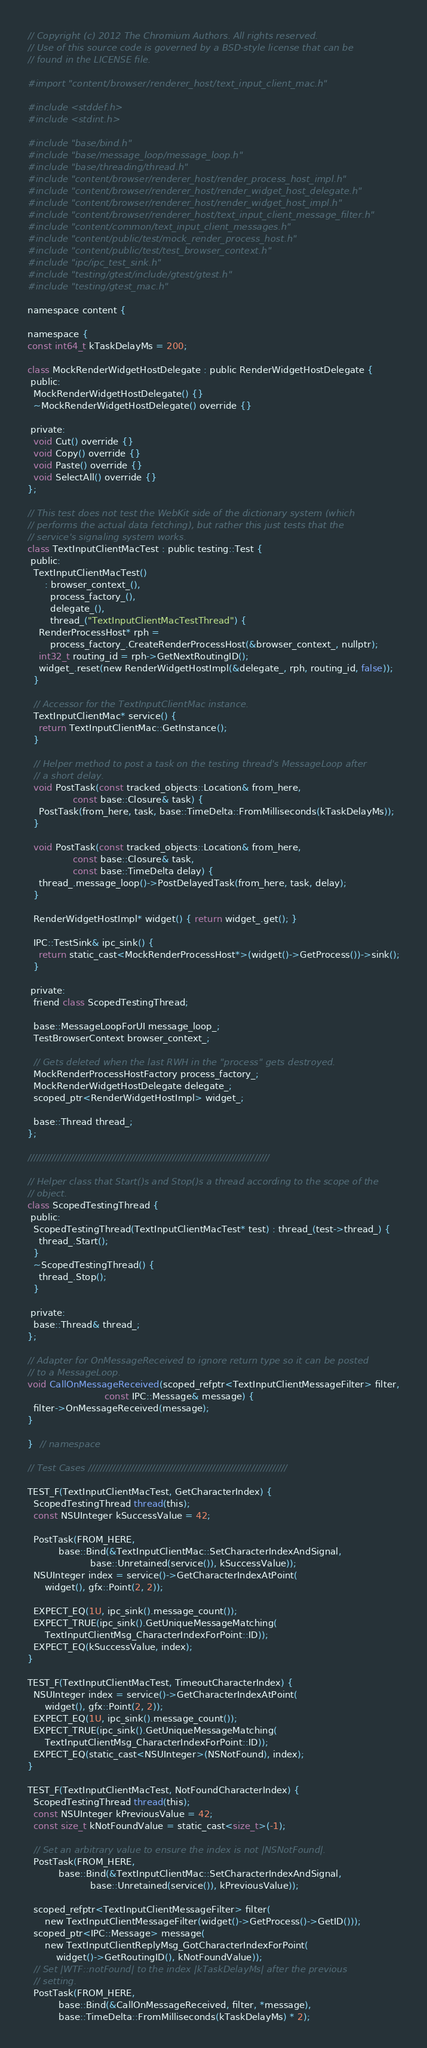<code> <loc_0><loc_0><loc_500><loc_500><_ObjectiveC_>// Copyright (c) 2012 The Chromium Authors. All rights reserved.
// Use of this source code is governed by a BSD-style license that can be
// found in the LICENSE file.

#import "content/browser/renderer_host/text_input_client_mac.h"

#include <stddef.h>
#include <stdint.h>

#include "base/bind.h"
#include "base/message_loop/message_loop.h"
#include "base/threading/thread.h"
#include "content/browser/renderer_host/render_process_host_impl.h"
#include "content/browser/renderer_host/render_widget_host_delegate.h"
#include "content/browser/renderer_host/render_widget_host_impl.h"
#include "content/browser/renderer_host/text_input_client_message_filter.h"
#include "content/common/text_input_client_messages.h"
#include "content/public/test/mock_render_process_host.h"
#include "content/public/test/test_browser_context.h"
#include "ipc/ipc_test_sink.h"
#include "testing/gtest/include/gtest/gtest.h"
#include "testing/gtest_mac.h"

namespace content {

namespace {
const int64_t kTaskDelayMs = 200;

class MockRenderWidgetHostDelegate : public RenderWidgetHostDelegate {
 public:
  MockRenderWidgetHostDelegate() {}
  ~MockRenderWidgetHostDelegate() override {}

 private:
  void Cut() override {}
  void Copy() override {}
  void Paste() override {}
  void SelectAll() override {}
};

// This test does not test the WebKit side of the dictionary system (which
// performs the actual data fetching), but rather this just tests that the
// service's signaling system works.
class TextInputClientMacTest : public testing::Test {
 public:
  TextInputClientMacTest()
      : browser_context_(),
        process_factory_(),
        delegate_(),
        thread_("TextInputClientMacTestThread") {
    RenderProcessHost* rph =
        process_factory_.CreateRenderProcessHost(&browser_context_, nullptr);
    int32_t routing_id = rph->GetNextRoutingID();
    widget_.reset(new RenderWidgetHostImpl(&delegate_, rph, routing_id, false));
  }

  // Accessor for the TextInputClientMac instance.
  TextInputClientMac* service() {
    return TextInputClientMac::GetInstance();
  }

  // Helper method to post a task on the testing thread's MessageLoop after
  // a short delay.
  void PostTask(const tracked_objects::Location& from_here,
                const base::Closure& task) {
    PostTask(from_here, task, base::TimeDelta::FromMilliseconds(kTaskDelayMs));
  }

  void PostTask(const tracked_objects::Location& from_here,
                const base::Closure& task,
                const base::TimeDelta delay) {
    thread_.message_loop()->PostDelayedTask(from_here, task, delay);
  }

  RenderWidgetHostImpl* widget() { return widget_.get(); }

  IPC::TestSink& ipc_sink() {
    return static_cast<MockRenderProcessHost*>(widget()->GetProcess())->sink();
  }

 private:
  friend class ScopedTestingThread;

  base::MessageLoopForUI message_loop_;
  TestBrowserContext browser_context_;

  // Gets deleted when the last RWH in the "process" gets destroyed.
  MockRenderProcessHostFactory process_factory_;
  MockRenderWidgetHostDelegate delegate_;
  scoped_ptr<RenderWidgetHostImpl> widget_;

  base::Thread thread_;
};

////////////////////////////////////////////////////////////////////////////////

// Helper class that Start()s and Stop()s a thread according to the scope of the
// object.
class ScopedTestingThread {
 public:
  ScopedTestingThread(TextInputClientMacTest* test) : thread_(test->thread_) {
    thread_.Start();
  }
  ~ScopedTestingThread() {
    thread_.Stop();
  }

 private:
  base::Thread& thread_;
};

// Adapter for OnMessageReceived to ignore return type so it can be posted
// to a MessageLoop.
void CallOnMessageReceived(scoped_refptr<TextInputClientMessageFilter> filter,
                           const IPC::Message& message) {
  filter->OnMessageReceived(message);
}

}  // namespace

// Test Cases //////////////////////////////////////////////////////////////////

TEST_F(TextInputClientMacTest, GetCharacterIndex) {
  ScopedTestingThread thread(this);
  const NSUInteger kSuccessValue = 42;

  PostTask(FROM_HERE,
           base::Bind(&TextInputClientMac::SetCharacterIndexAndSignal,
                      base::Unretained(service()), kSuccessValue));
  NSUInteger index = service()->GetCharacterIndexAtPoint(
      widget(), gfx::Point(2, 2));

  EXPECT_EQ(1U, ipc_sink().message_count());
  EXPECT_TRUE(ipc_sink().GetUniqueMessageMatching(
      TextInputClientMsg_CharacterIndexForPoint::ID));
  EXPECT_EQ(kSuccessValue, index);
}

TEST_F(TextInputClientMacTest, TimeoutCharacterIndex) {
  NSUInteger index = service()->GetCharacterIndexAtPoint(
      widget(), gfx::Point(2, 2));
  EXPECT_EQ(1U, ipc_sink().message_count());
  EXPECT_TRUE(ipc_sink().GetUniqueMessageMatching(
      TextInputClientMsg_CharacterIndexForPoint::ID));
  EXPECT_EQ(static_cast<NSUInteger>(NSNotFound), index);
}

TEST_F(TextInputClientMacTest, NotFoundCharacterIndex) {
  ScopedTestingThread thread(this);
  const NSUInteger kPreviousValue = 42;
  const size_t kNotFoundValue = static_cast<size_t>(-1);

  // Set an arbitrary value to ensure the index is not |NSNotFound|.
  PostTask(FROM_HERE,
           base::Bind(&TextInputClientMac::SetCharacterIndexAndSignal,
                      base::Unretained(service()), kPreviousValue));

  scoped_refptr<TextInputClientMessageFilter> filter(
      new TextInputClientMessageFilter(widget()->GetProcess()->GetID()));
  scoped_ptr<IPC::Message> message(
      new TextInputClientReplyMsg_GotCharacterIndexForPoint(
          widget()->GetRoutingID(), kNotFoundValue));
  // Set |WTF::notFound| to the index |kTaskDelayMs| after the previous
  // setting.
  PostTask(FROM_HERE,
           base::Bind(&CallOnMessageReceived, filter, *message),
           base::TimeDelta::FromMilliseconds(kTaskDelayMs) * 2);
</code> 